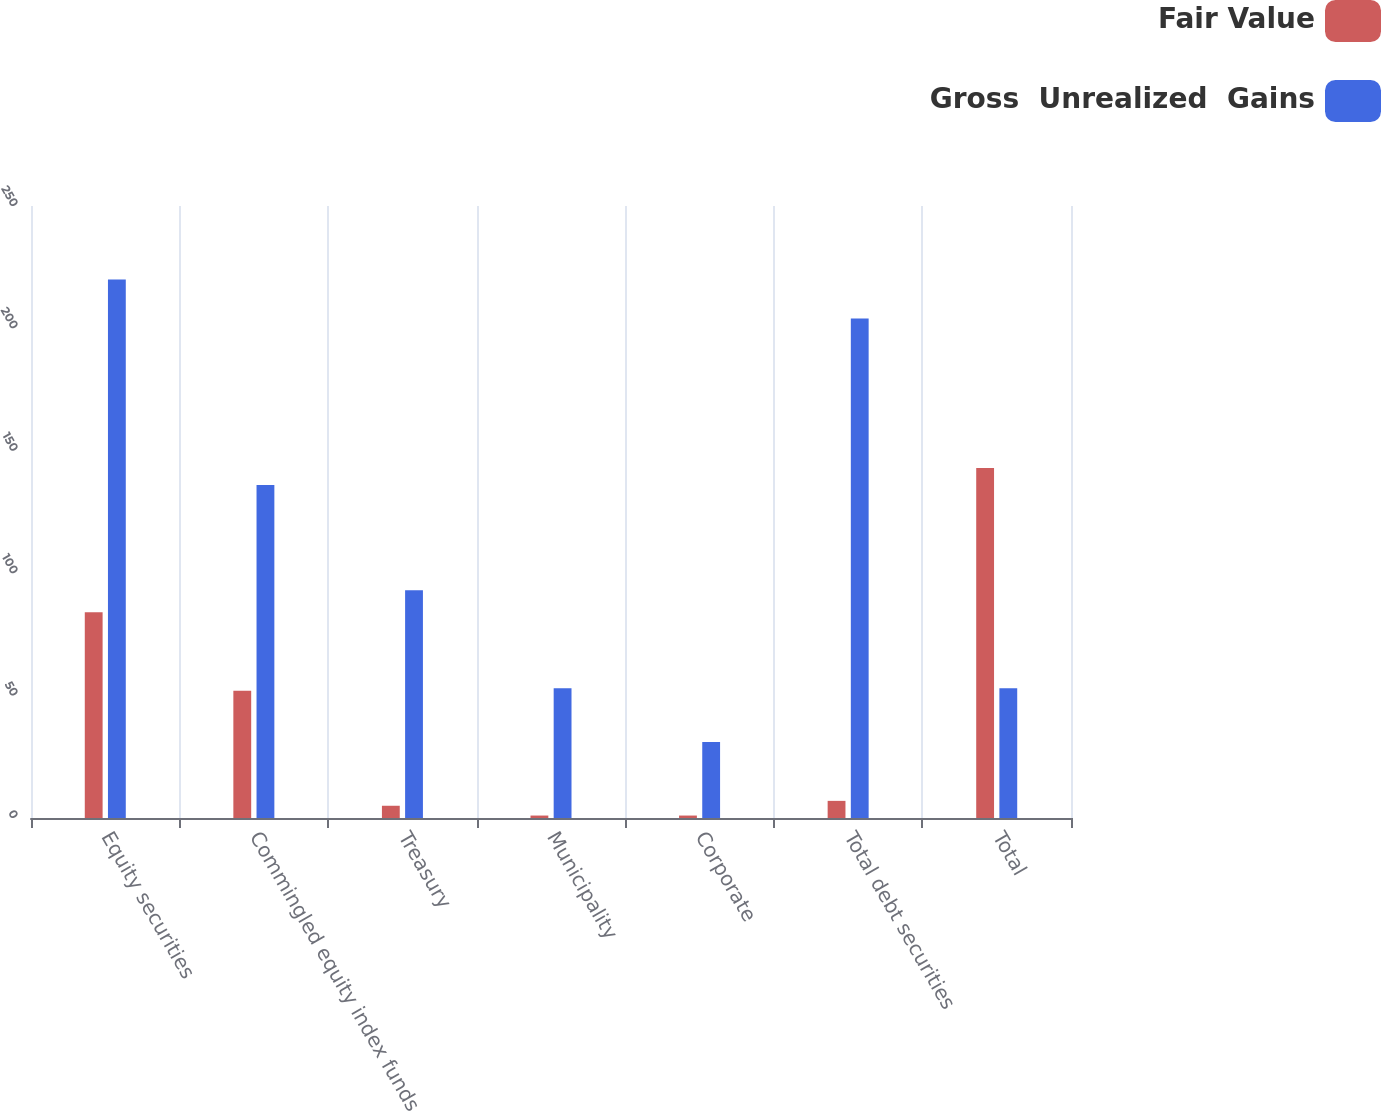Convert chart. <chart><loc_0><loc_0><loc_500><loc_500><stacked_bar_chart><ecel><fcel>Equity securities<fcel>Commingled equity index funds<fcel>Treasury<fcel>Municipality<fcel>Corporate<fcel>Total debt securities<fcel>Total<nl><fcel>Fair Value<fcel>84<fcel>52<fcel>5<fcel>1<fcel>1<fcel>7<fcel>143<nl><fcel>Gross  Unrealized  Gains<fcel>220<fcel>136<fcel>93<fcel>53<fcel>31<fcel>204<fcel>53<nl></chart> 